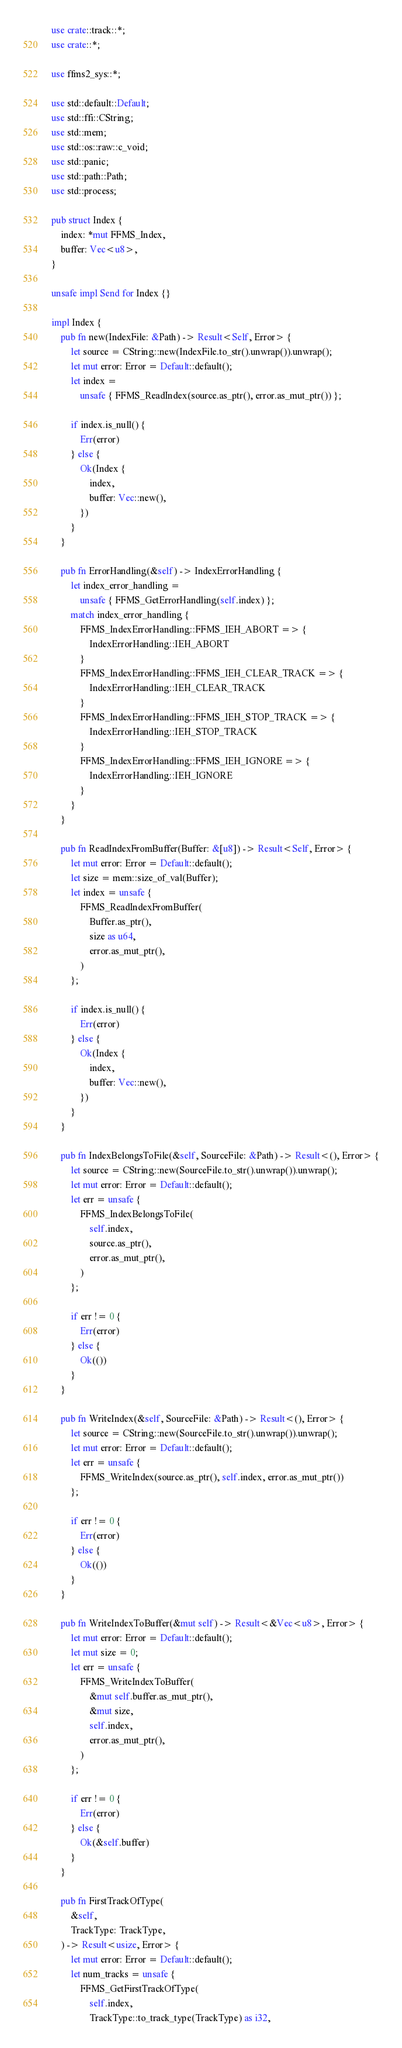Convert code to text. <code><loc_0><loc_0><loc_500><loc_500><_Rust_>use crate::track::*;
use crate::*;

use ffms2_sys::*;

use std::default::Default;
use std::ffi::CString;
use std::mem;
use std::os::raw::c_void;
use std::panic;
use std::path::Path;
use std::process;

pub struct Index {
    index: *mut FFMS_Index,
    buffer: Vec<u8>,
}

unsafe impl Send for Index {}

impl Index {
    pub fn new(IndexFile: &Path) -> Result<Self, Error> {
        let source = CString::new(IndexFile.to_str().unwrap()).unwrap();
        let mut error: Error = Default::default();
        let index =
            unsafe { FFMS_ReadIndex(source.as_ptr(), error.as_mut_ptr()) };

        if index.is_null() {
            Err(error)
        } else {
            Ok(Index {
                index,
                buffer: Vec::new(),
            })
        }
    }

    pub fn ErrorHandling(&self) -> IndexErrorHandling {
        let index_error_handling =
            unsafe { FFMS_GetErrorHandling(self.index) };
        match index_error_handling {
            FFMS_IndexErrorHandling::FFMS_IEH_ABORT => {
                IndexErrorHandling::IEH_ABORT
            }
            FFMS_IndexErrorHandling::FFMS_IEH_CLEAR_TRACK => {
                IndexErrorHandling::IEH_CLEAR_TRACK
            }
            FFMS_IndexErrorHandling::FFMS_IEH_STOP_TRACK => {
                IndexErrorHandling::IEH_STOP_TRACK
            }
            FFMS_IndexErrorHandling::FFMS_IEH_IGNORE => {
                IndexErrorHandling::IEH_IGNORE
            }
        }
    }

    pub fn ReadIndexFromBuffer(Buffer: &[u8]) -> Result<Self, Error> {
        let mut error: Error = Default::default();
        let size = mem::size_of_val(Buffer);
        let index = unsafe {
            FFMS_ReadIndexFromBuffer(
                Buffer.as_ptr(),
                size as u64,
                error.as_mut_ptr(),
            )
        };

        if index.is_null() {
            Err(error)
        } else {
            Ok(Index {
                index,
                buffer: Vec::new(),
            })
        }
    }

    pub fn IndexBelongsToFile(&self, SourceFile: &Path) -> Result<(), Error> {
        let source = CString::new(SourceFile.to_str().unwrap()).unwrap();
        let mut error: Error = Default::default();
        let err = unsafe {
            FFMS_IndexBelongsToFile(
                self.index,
                source.as_ptr(),
                error.as_mut_ptr(),
            )
        };

        if err != 0 {
            Err(error)
        } else {
            Ok(())
        }
    }

    pub fn WriteIndex(&self, SourceFile: &Path) -> Result<(), Error> {
        let source = CString::new(SourceFile.to_str().unwrap()).unwrap();
        let mut error: Error = Default::default();
        let err = unsafe {
            FFMS_WriteIndex(source.as_ptr(), self.index, error.as_mut_ptr())
        };

        if err != 0 {
            Err(error)
        } else {
            Ok(())
        }
    }

    pub fn WriteIndexToBuffer(&mut self) -> Result<&Vec<u8>, Error> {
        let mut error: Error = Default::default();
        let mut size = 0;
        let err = unsafe {
            FFMS_WriteIndexToBuffer(
                &mut self.buffer.as_mut_ptr(),
                &mut size,
                self.index,
                error.as_mut_ptr(),
            )
        };

        if err != 0 {
            Err(error)
        } else {
            Ok(&self.buffer)
        }
    }

    pub fn FirstTrackOfType(
        &self,
        TrackType: TrackType,
    ) -> Result<usize, Error> {
        let mut error: Error = Default::default();
        let num_tracks = unsafe {
            FFMS_GetFirstTrackOfType(
                self.index,
                TrackType::to_track_type(TrackType) as i32,</code> 